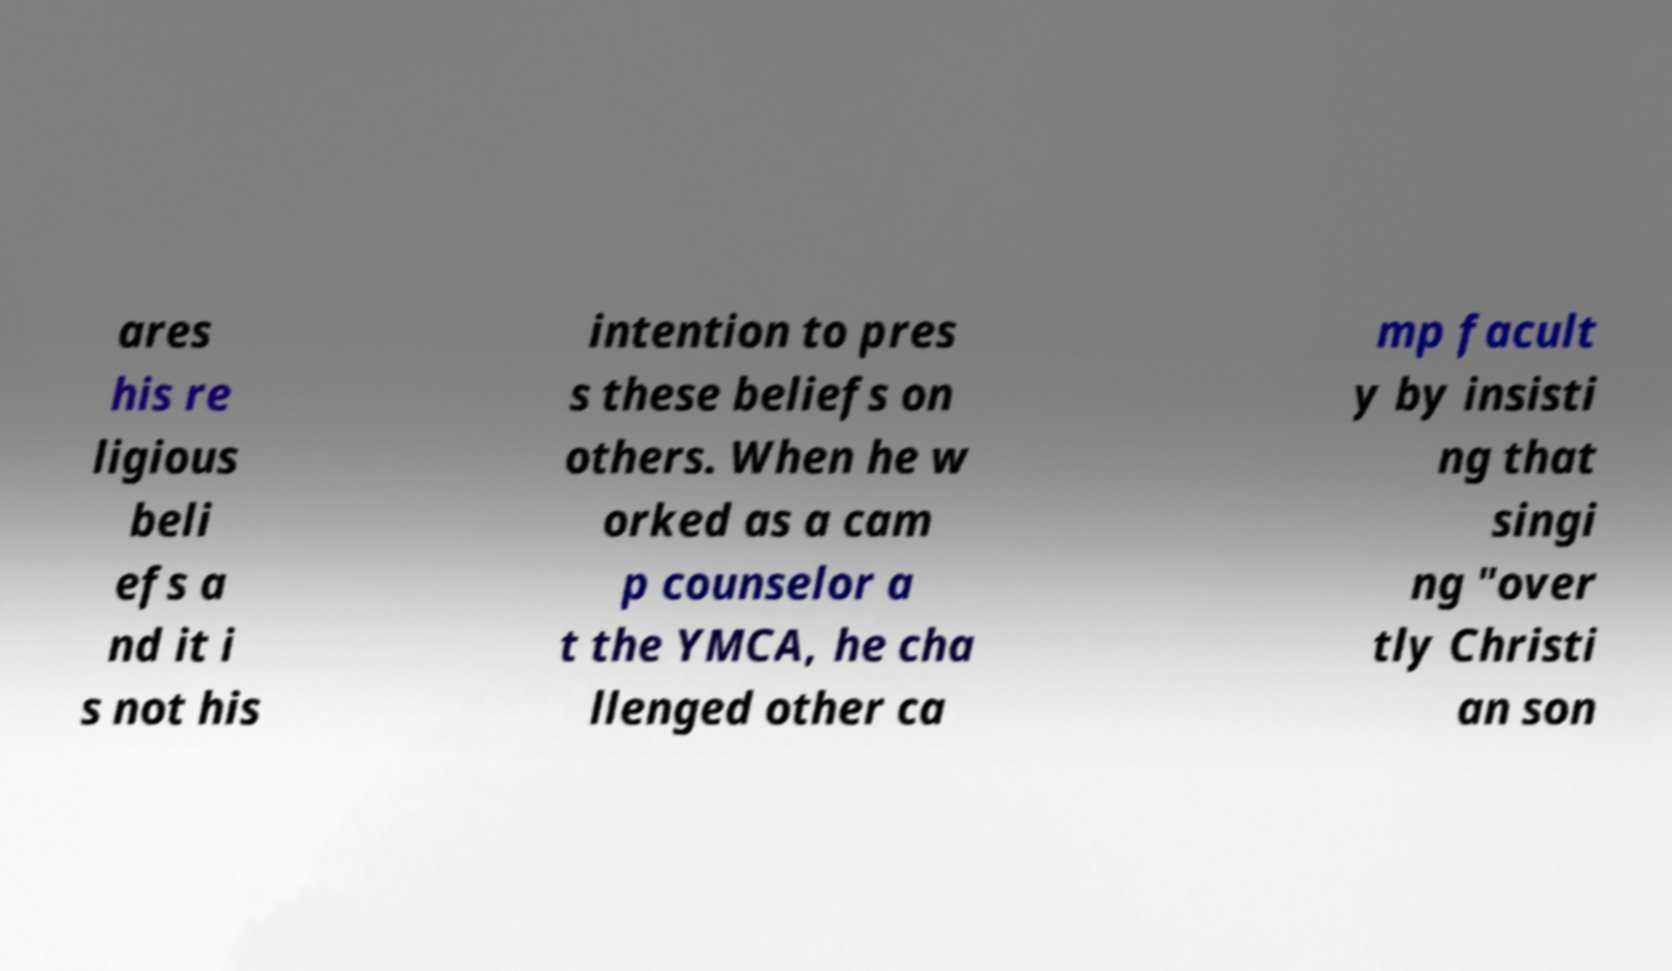For documentation purposes, I need the text within this image transcribed. Could you provide that? ares his re ligious beli efs a nd it i s not his intention to pres s these beliefs on others. When he w orked as a cam p counselor a t the YMCA, he cha llenged other ca mp facult y by insisti ng that singi ng "over tly Christi an son 